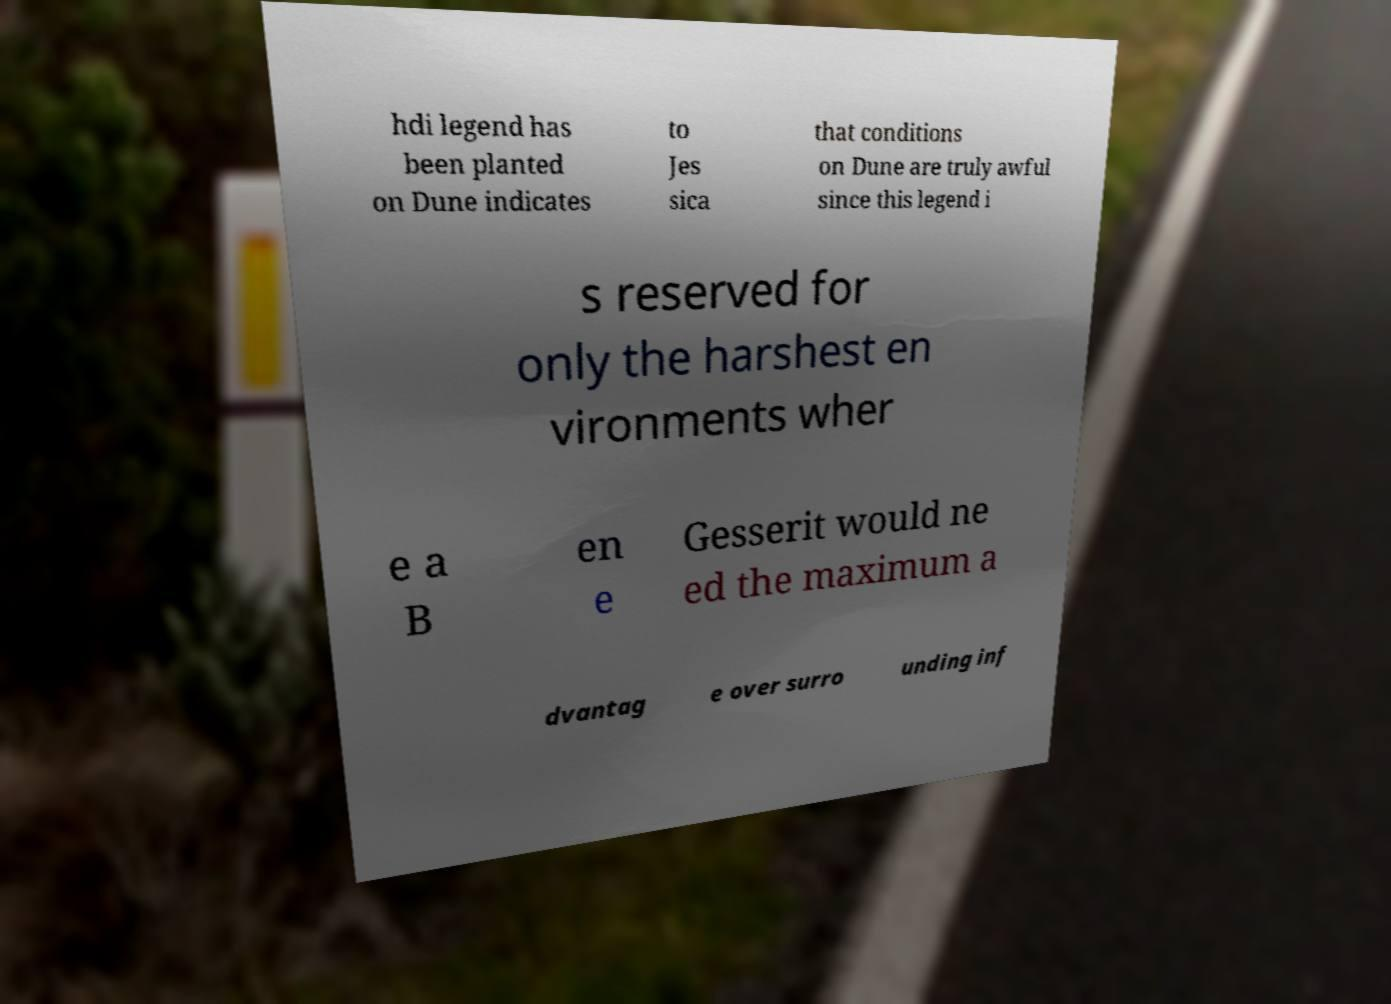Can you read and provide the text displayed in the image?This photo seems to have some interesting text. Can you extract and type it out for me? hdi legend has been planted on Dune indicates to Jes sica that conditions on Dune are truly awful since this legend i s reserved for only the harshest en vironments wher e a B en e Gesserit would ne ed the maximum a dvantag e over surro unding inf 